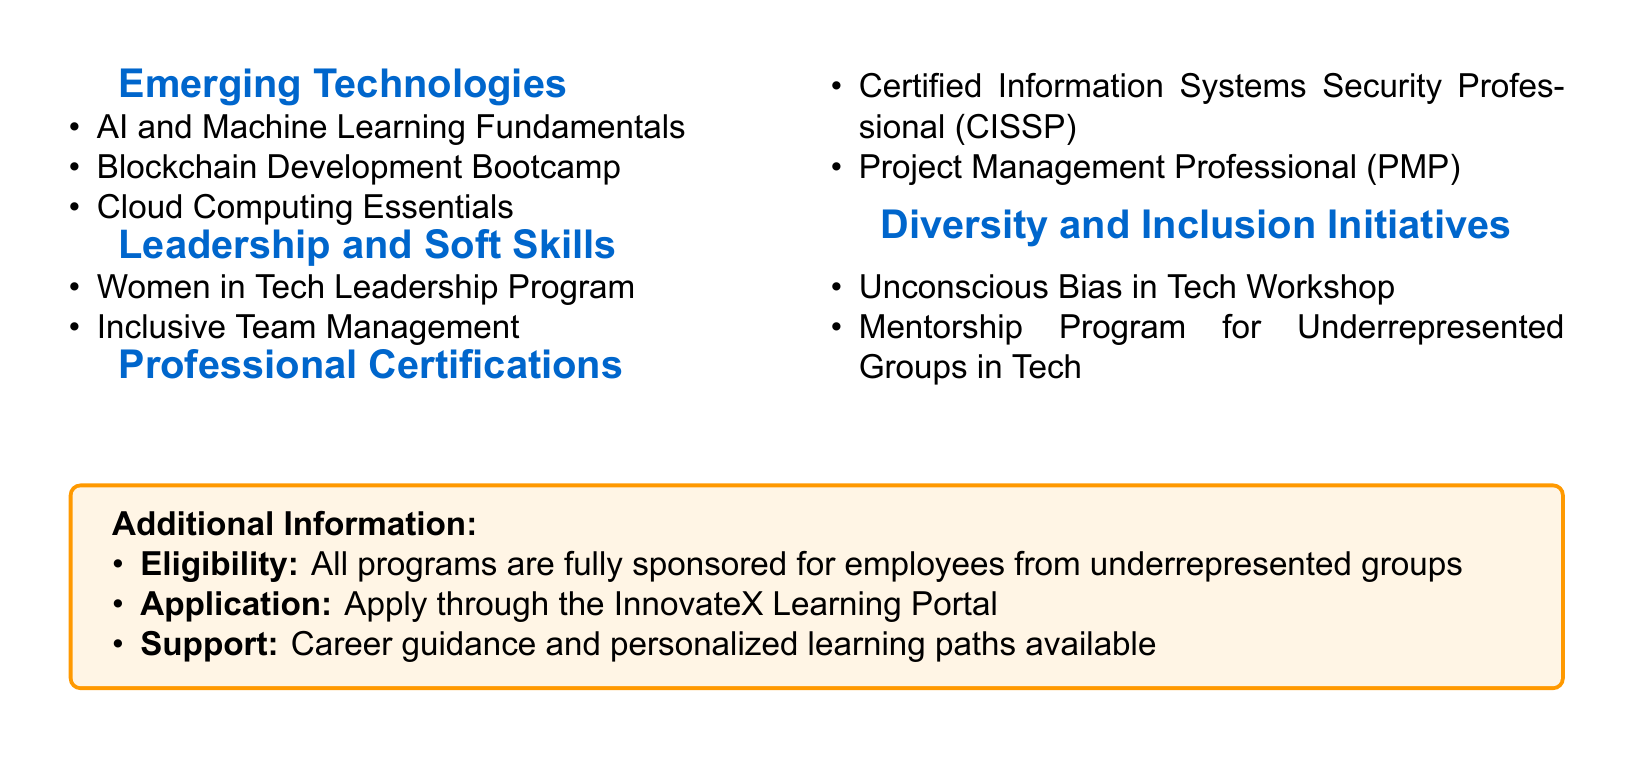What programs are available under Emerging Technologies? The document lists the various programs under the section Emerging Technologies, including AI and Machine Learning Fundamentals, Blockchain Development Bootcamp, and Cloud Computing Essentials.
Answer: AI and Machine Learning Fundamentals, Blockchain Development Bootcamp, Cloud Computing Essentials What certification is mentioned for security professionals? The document specifies professional certifications, including the Certified Information Systems Security Professional as one of the options.
Answer: Certified Information Systems Security Professional (CISSP) How many programs are listed under Leadership and Soft Skills? The document provides a total count of programs in the Leadership and Soft Skills section, which includes Women in Tech Leadership Program and Inclusive Team Management, totaling two programs.
Answer: Two Which program focuses on bias in technology? The document mentions specific initiatives under Diversity and Inclusion, including a workshop that addresses unconscious bias in tech.
Answer: Unconscious Bias in Tech Workshop Who is eligible for the company-sponsored educational programs? The document states that all programs are fully sponsored for a specific group of employees, indicating the inclusivity of the initiatives.
Answer: Employees from underrepresented groups 